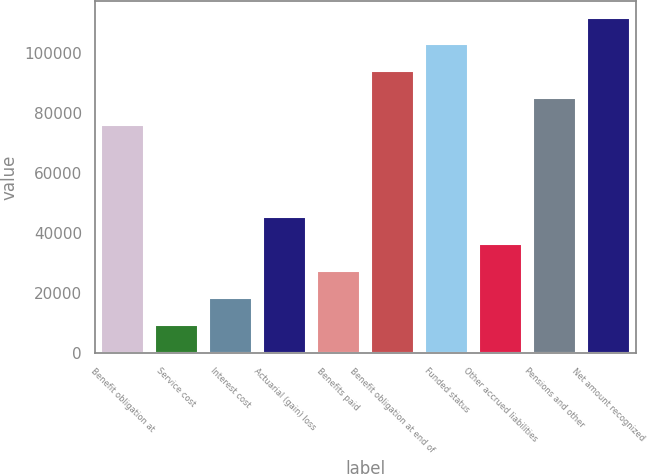Convert chart. <chart><loc_0><loc_0><loc_500><loc_500><bar_chart><fcel>Benefit obligation at<fcel>Service cost<fcel>Interest cost<fcel>Actuarial (gain) loss<fcel>Benefits paid<fcel>Benefit obligation at end of<fcel>Funded status<fcel>Other accrued liabilities<fcel>Pensions and other<fcel>Net amount recognized<nl><fcel>75953<fcel>9478.9<fcel>18401.8<fcel>45170.5<fcel>27324.7<fcel>93798.8<fcel>102722<fcel>36247.6<fcel>84875.9<fcel>111645<nl></chart> 